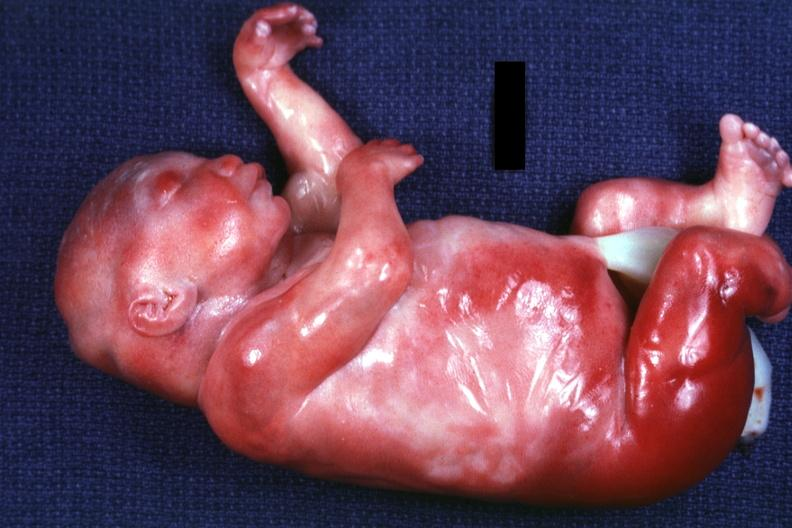what is present of kidneys?
Answer the question using a single word or phrase. Polycystic disease 